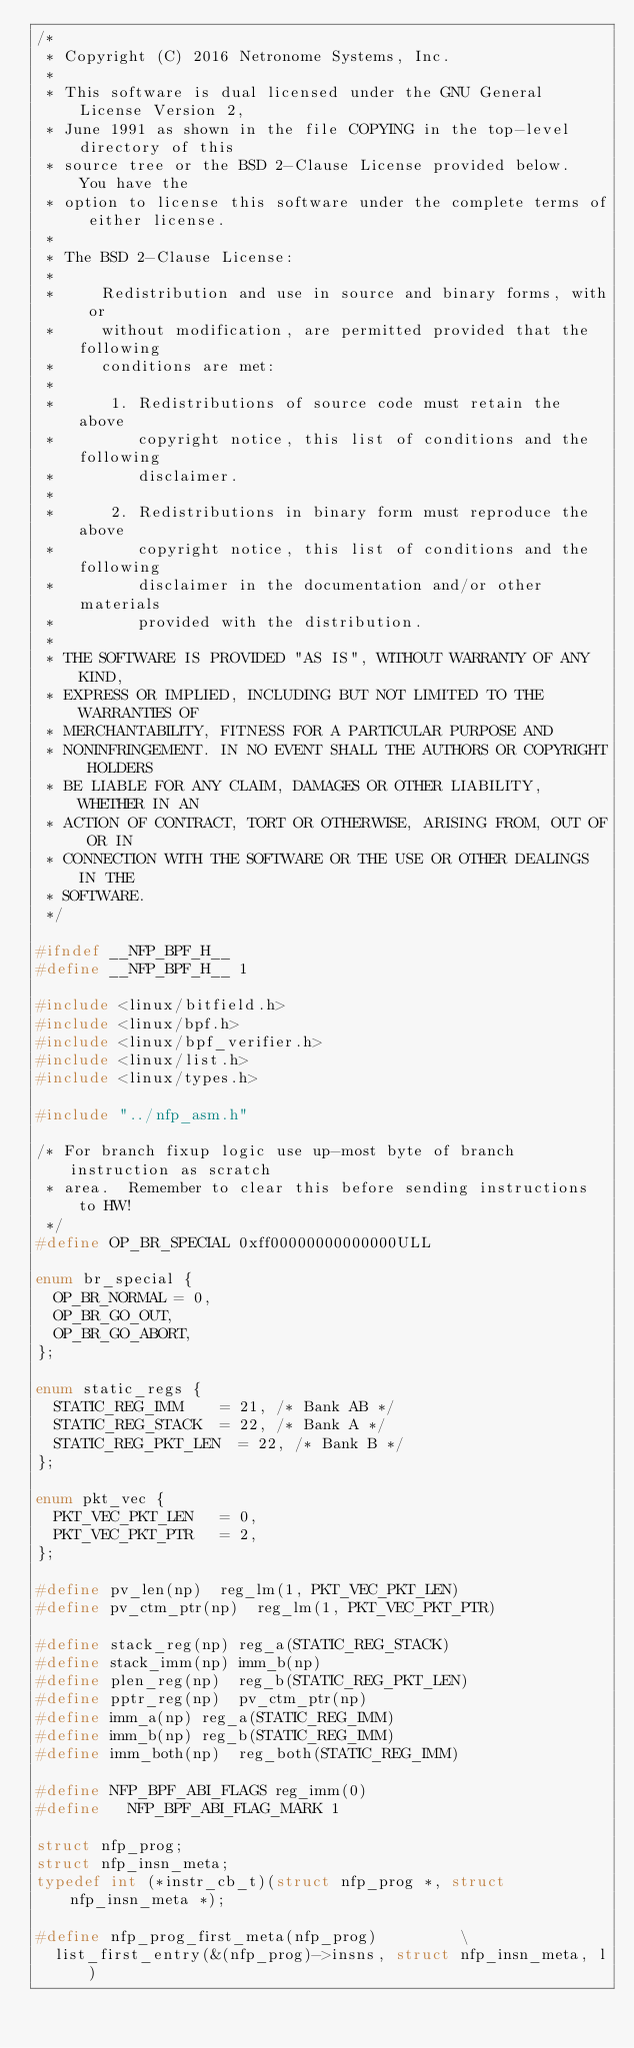Convert code to text. <code><loc_0><loc_0><loc_500><loc_500><_C_>/*
 * Copyright (C) 2016 Netronome Systems, Inc.
 *
 * This software is dual licensed under the GNU General License Version 2,
 * June 1991 as shown in the file COPYING in the top-level directory of this
 * source tree or the BSD 2-Clause License provided below.  You have the
 * option to license this software under the complete terms of either license.
 *
 * The BSD 2-Clause License:
 *
 *     Redistribution and use in source and binary forms, with or
 *     without modification, are permitted provided that the following
 *     conditions are met:
 *
 *      1. Redistributions of source code must retain the above
 *         copyright notice, this list of conditions and the following
 *         disclaimer.
 *
 *      2. Redistributions in binary form must reproduce the above
 *         copyright notice, this list of conditions and the following
 *         disclaimer in the documentation and/or other materials
 *         provided with the distribution.
 *
 * THE SOFTWARE IS PROVIDED "AS IS", WITHOUT WARRANTY OF ANY KIND,
 * EXPRESS OR IMPLIED, INCLUDING BUT NOT LIMITED TO THE WARRANTIES OF
 * MERCHANTABILITY, FITNESS FOR A PARTICULAR PURPOSE AND
 * NONINFRINGEMENT. IN NO EVENT SHALL THE AUTHORS OR COPYRIGHT HOLDERS
 * BE LIABLE FOR ANY CLAIM, DAMAGES OR OTHER LIABILITY, WHETHER IN AN
 * ACTION OF CONTRACT, TORT OR OTHERWISE, ARISING FROM, OUT OF OR IN
 * CONNECTION WITH THE SOFTWARE OR THE USE OR OTHER DEALINGS IN THE
 * SOFTWARE.
 */

#ifndef __NFP_BPF_H__
#define __NFP_BPF_H__ 1

#include <linux/bitfield.h>
#include <linux/bpf.h>
#include <linux/bpf_verifier.h>
#include <linux/list.h>
#include <linux/types.h>

#include "../nfp_asm.h"

/* For branch fixup logic use up-most byte of branch instruction as scratch
 * area.  Remember to clear this before sending instructions to HW!
 */
#define OP_BR_SPECIAL	0xff00000000000000ULL

enum br_special {
	OP_BR_NORMAL = 0,
	OP_BR_GO_OUT,
	OP_BR_GO_ABORT,
};

enum static_regs {
	STATIC_REG_IMM		= 21, /* Bank AB */
	STATIC_REG_STACK	= 22, /* Bank A */
	STATIC_REG_PKT_LEN	= 22, /* Bank B */
};

enum pkt_vec {
	PKT_VEC_PKT_LEN		= 0,
	PKT_VEC_PKT_PTR		= 2,
};

#define pv_len(np)	reg_lm(1, PKT_VEC_PKT_LEN)
#define pv_ctm_ptr(np)	reg_lm(1, PKT_VEC_PKT_PTR)

#define stack_reg(np)	reg_a(STATIC_REG_STACK)
#define stack_imm(np)	imm_b(np)
#define plen_reg(np)	reg_b(STATIC_REG_PKT_LEN)
#define pptr_reg(np)	pv_ctm_ptr(np)
#define imm_a(np)	reg_a(STATIC_REG_IMM)
#define imm_b(np)	reg_b(STATIC_REG_IMM)
#define imm_both(np)	reg_both(STATIC_REG_IMM)

#define NFP_BPF_ABI_FLAGS	reg_imm(0)
#define   NFP_BPF_ABI_FLAG_MARK	1

struct nfp_prog;
struct nfp_insn_meta;
typedef int (*instr_cb_t)(struct nfp_prog *, struct nfp_insn_meta *);

#define nfp_prog_first_meta(nfp_prog)					\
	list_first_entry(&(nfp_prog)->insns, struct nfp_insn_meta, l)</code> 